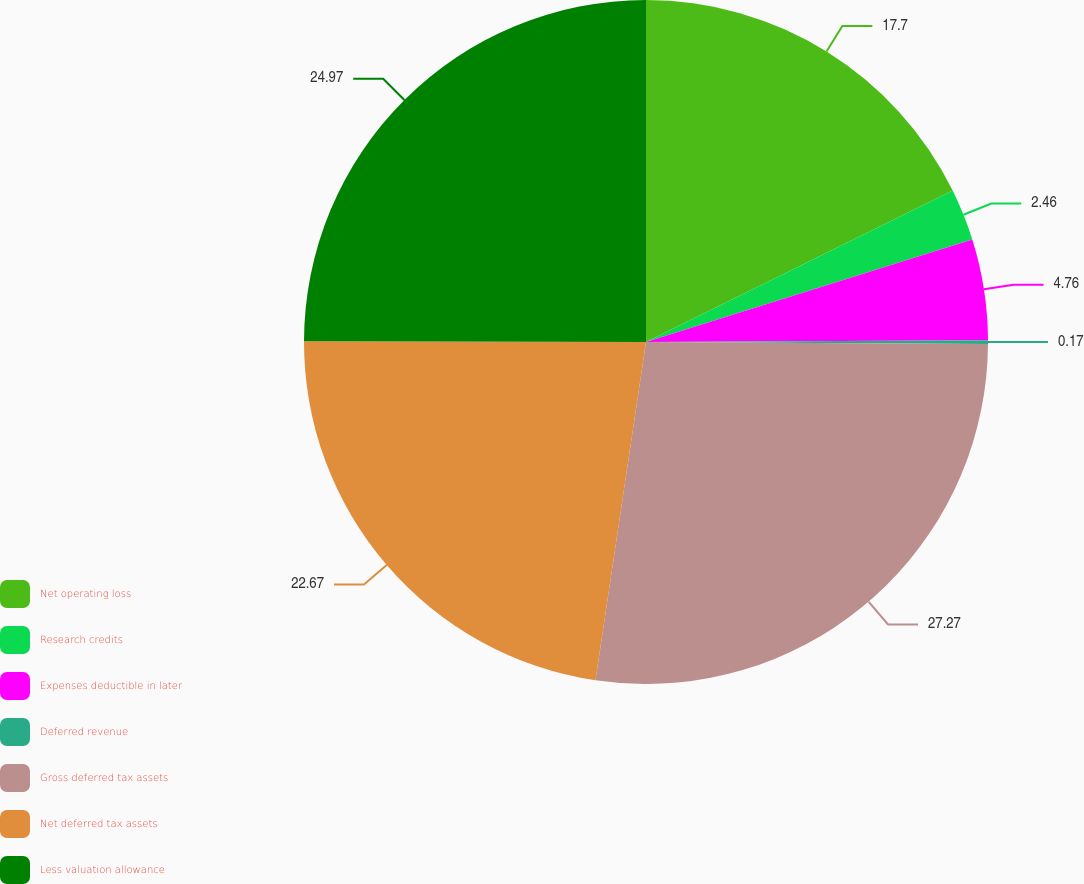Convert chart to OTSL. <chart><loc_0><loc_0><loc_500><loc_500><pie_chart><fcel>Net operating loss<fcel>Research credits<fcel>Expenses deductible in later<fcel>Deferred revenue<fcel>Gross deferred tax assets<fcel>Net deferred tax assets<fcel>Less valuation allowance<nl><fcel>17.7%<fcel>2.46%<fcel>4.76%<fcel>0.17%<fcel>27.27%<fcel>22.67%<fcel>24.97%<nl></chart> 